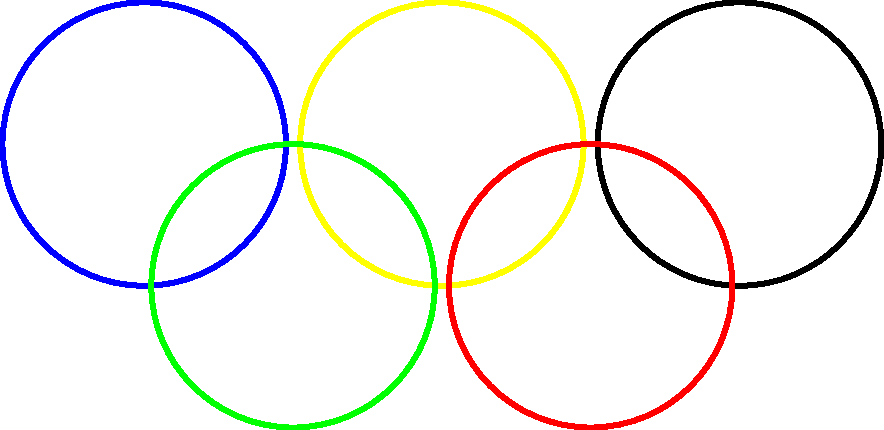In the Olympic rings symbol, what is the ratio of the distance between the centers of adjacent rings to the diameter of a single ring? Let's approach this step-by-step:

1) First, we need to understand the geometry of the Olympic rings. The symbol consists of five interlocking rings of equal size.

2) Let's denote the radius of each ring as $r$. Therefore, the diameter of each ring is $2r$.

3) Now, let's consider the distance between the centers of adjacent rings. In the standard configuration, this distance is 1.1 times the diameter of a single ring.

4) We can express this mathematically as:
   Distance between centers = $1.1 \times 2r = 2.2r$

5) Now, we need to find the ratio of this distance to the diameter of a single ring:

   Ratio = $\frac{\text{Distance between centers}}{\text{Diameter of a ring}}$
   
   $= \frac{2.2r}{2r}$
   
   $= 1.1$

6) This ratio of 1.1 is a standard in the official Olympic rings design, ensuring that the rings are properly interlocked without too much overlap or separation.
Answer: 1.1 